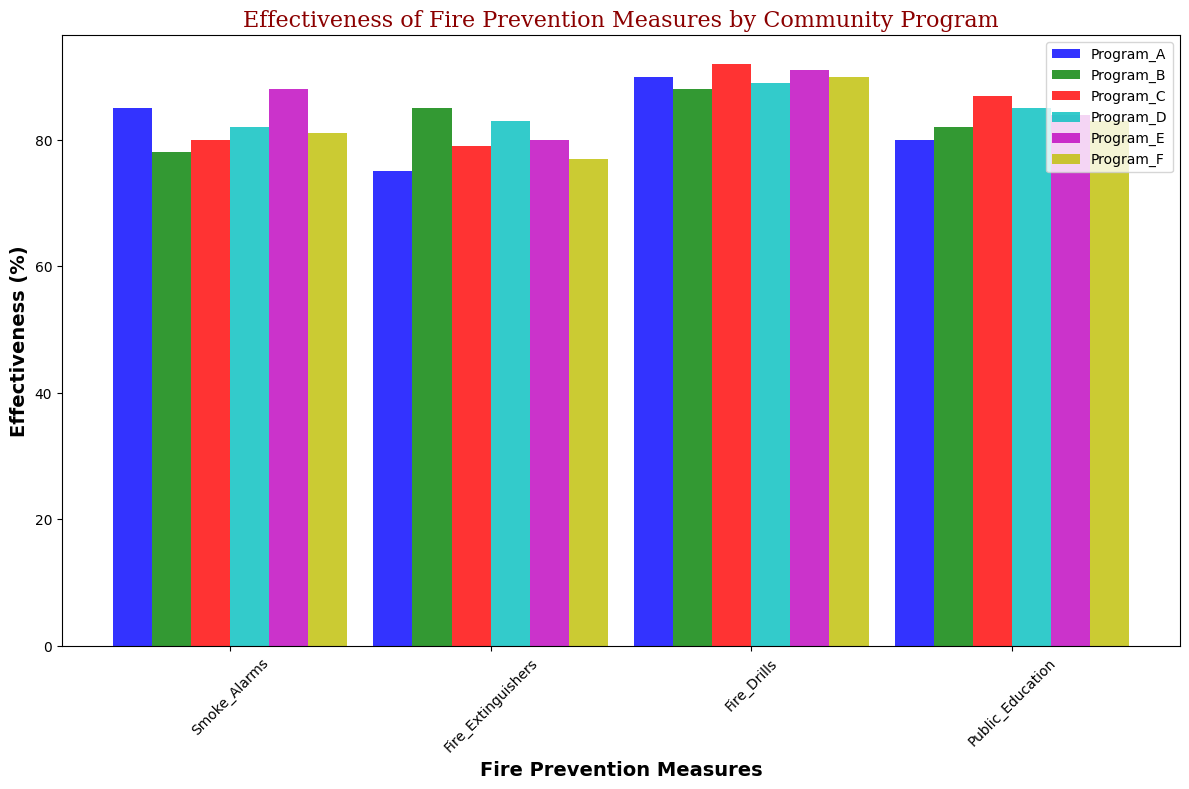Which community program shows the highest effectiveness for Fire Drills? Identify the height of the bars representing Fire Drills across all community programs and find the tallest one. Program C has the highest bar for Fire Drills with an effectiveness of 92%.
Answer: Program C Which fire prevention measure in Program B has the lowest effectiveness? Compare the height of the bars for each measure within Program B. The shortest bar is for Smoke Alarms with an effectiveness of 78%.
Answer: Smoke Alarms What is the average effectiveness of the Smoke Alarms measure across all community programs? Sum the effectiveness values for Smoke Alarms across all programs (85 + 78 + 80 + 82 + 88 + 81) = 494 and divide by the number of programs (6). The average is 494/6 = 82.33.
Answer: 82.33 Which measure has the greatest variation in effectiveness across all programs? Compare the range (max - min) of effectiveness values for each measure. Fire Extinguishers have the highest range: max is 85 (Program B) and min is 75 (Program A), so 85-75=10.
Answer: Fire Extinguishers Which program recorded the highest overall effectiveness, when considering all measures? Add the effectiveness values for all measures in each program, then compare the totals. Program C's total is 80 + 79 + 92 + 87 = 338, which is the highest.
Answer: Program C What is the combined effectiveness of Fire Drills and Public Education in Program A? Add the effectiveness values of Fire Drills and Public Education in Program A (90 + 80). The total effectiveness is 170.
Answer: 170 Is the effectiveness of Fire Extinguishers in Program D higher than in Program F? Compare the height of the bars for Fire Extinguishers in Program D and F. Program D's effectiveness (83) is higher than Program F's (77).
Answer: Yes What is the total difference in effectiveness between Smoke Alarms and Fire Extinguishers across all programs? Calculate the effectiveness difference for each program and sum them (85-75 + 78-85 + 80-79 + 82-83 + 88-80 + 81-77). The total difference is 85-75 + 78-85 + 80-79 + 82-83 + 88-80 + 81-77 = 23.
Answer: 23 